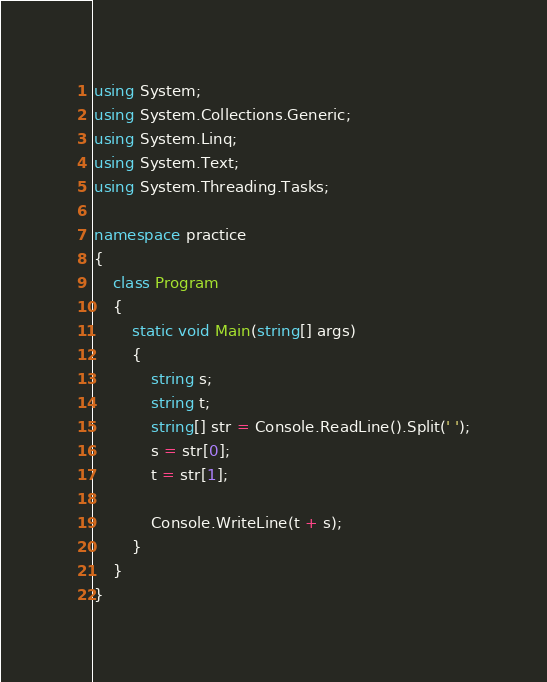<code> <loc_0><loc_0><loc_500><loc_500><_C#_>using System;
using System.Collections.Generic;
using System.Linq;
using System.Text;
using System.Threading.Tasks;

namespace practice
{
    class Program
    {
        static void Main(string[] args)
        {
            string s;
            string t;
            string[] str = Console.ReadLine().Split(' ');
            s = str[0];
            t = str[1];

            Console.WriteLine(t + s);
        }
    }
}</code> 